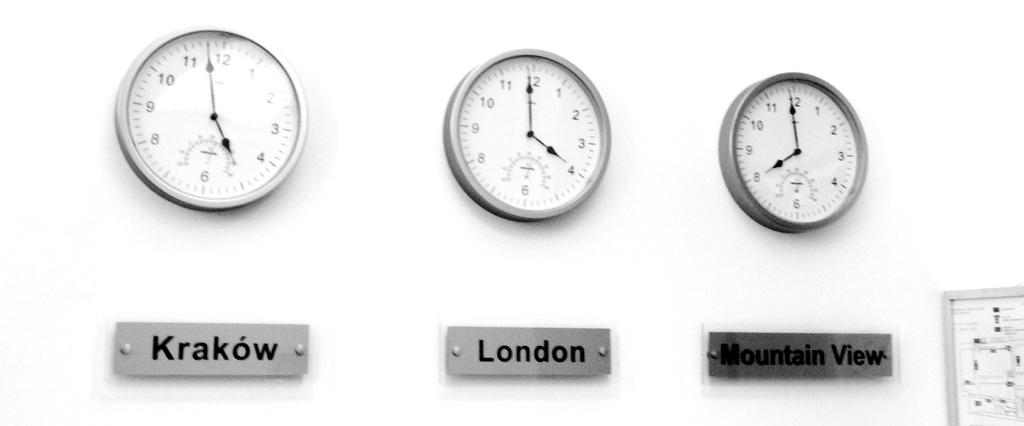<image>
Describe the image concisely. A bank of clocks showing the times in Krakow, London and Mountain View. 